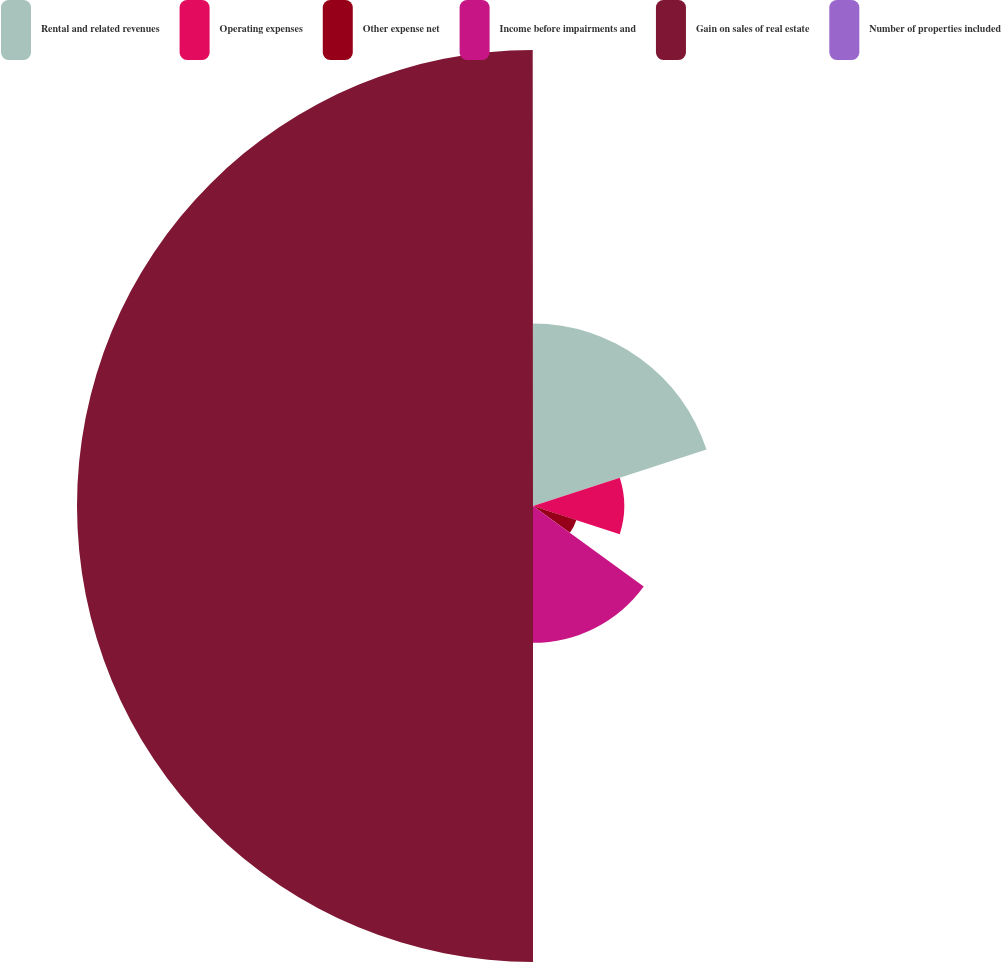<chart> <loc_0><loc_0><loc_500><loc_500><pie_chart><fcel>Rental and related revenues<fcel>Operating expenses<fcel>Other expense net<fcel>Income before impairments and<fcel>Gain on sales of real estate<fcel>Number of properties included<nl><fcel>20.0%<fcel>10.0%<fcel>5.0%<fcel>15.0%<fcel>49.99%<fcel>0.01%<nl></chart> 